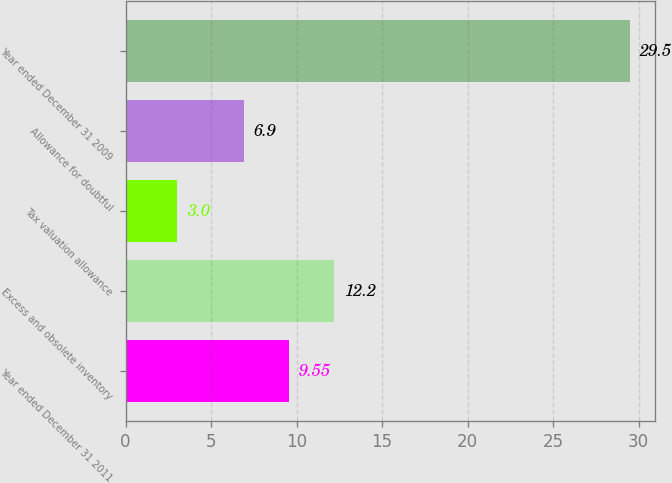Convert chart to OTSL. <chart><loc_0><loc_0><loc_500><loc_500><bar_chart><fcel>Year ended December 31 2011<fcel>Excess and obsolete inventory<fcel>Tax valuation allowance<fcel>Allowance for doubtful<fcel>Year ended December 31 2009<nl><fcel>9.55<fcel>12.2<fcel>3<fcel>6.9<fcel>29.5<nl></chart> 